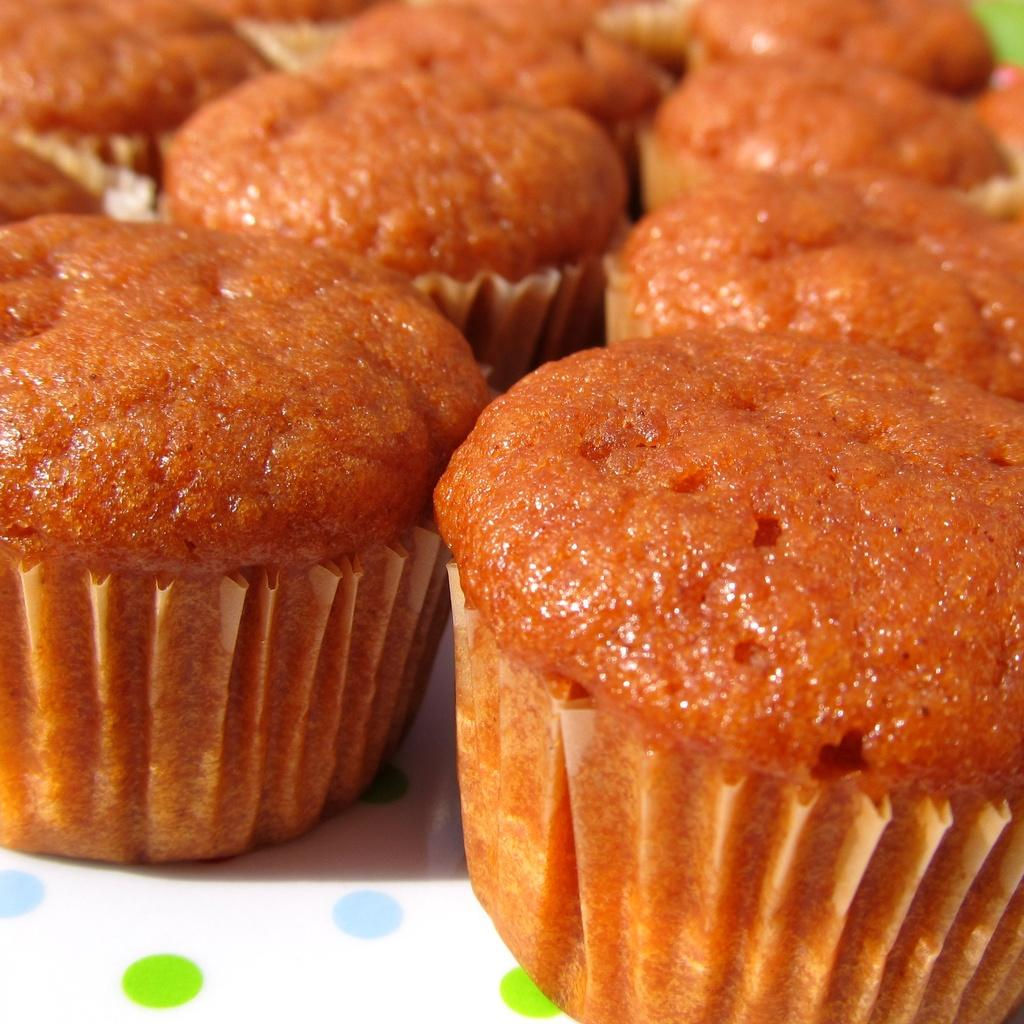What type of food is featured in the image? There are many cupcakes in the image. What color are the cupcakes? The cupcakes are brown in color. What is the color of the surface on which the cupcakes are placed? The cupcakes are on a white surface. Where is the rabbit hiding in the image? There is no rabbit present in the image. What type of club is visible in the image? There is no club present in the image. 